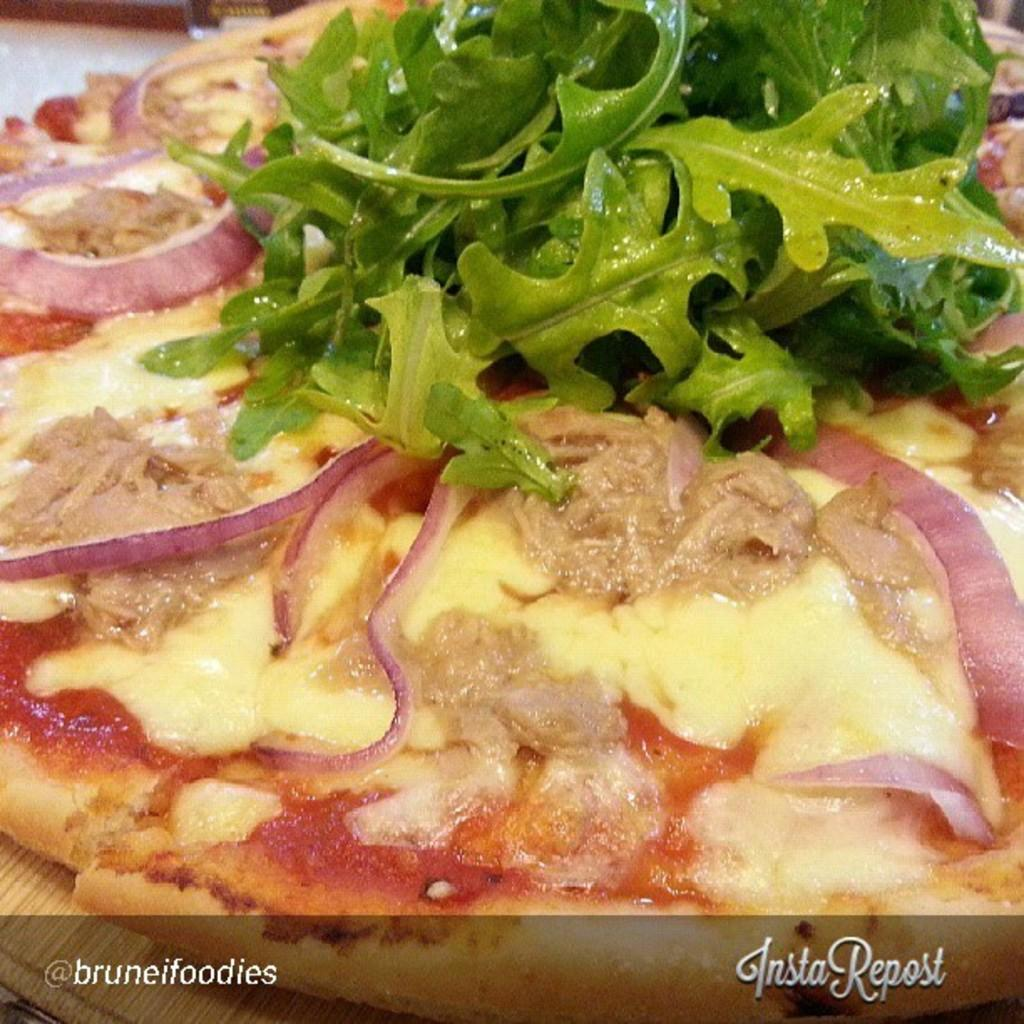What is the main subject of the image? The main subject of the image is a pizza. Can you describe the pizza in the image? The image is a zoomed in picture of a pizza. Is there any text present in the image? Yes, there is text at the bottom of the image. What type of crown can be seen on top of the pizza in the image? There is no crown present on top of the pizza in the image. Can you describe the field where the pizza was made in the image? There is no field mentioned or depicted in the image; it is a close-up picture of a pizza. 